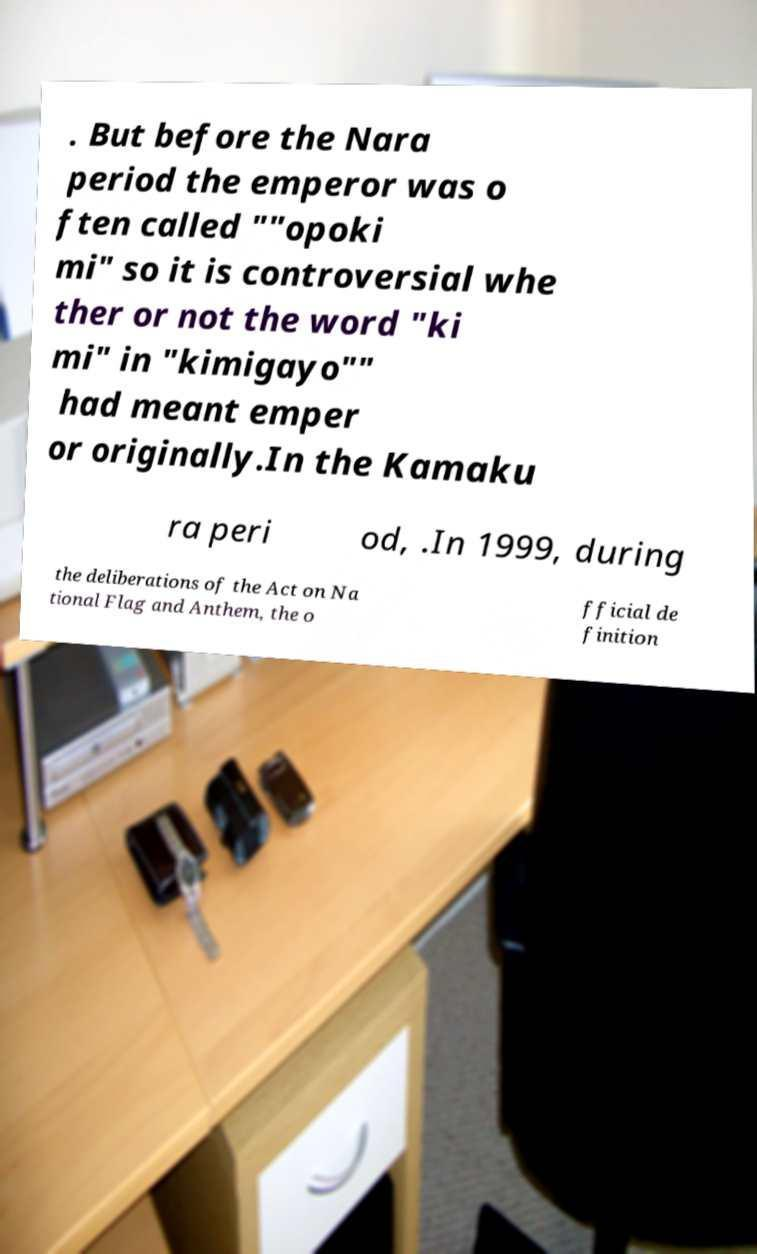Please identify and transcribe the text found in this image. . But before the Nara period the emperor was o ften called ""opoki mi" so it is controversial whe ther or not the word "ki mi" in "kimigayo"" had meant emper or originally.In the Kamaku ra peri od, .In 1999, during the deliberations of the Act on Na tional Flag and Anthem, the o fficial de finition 